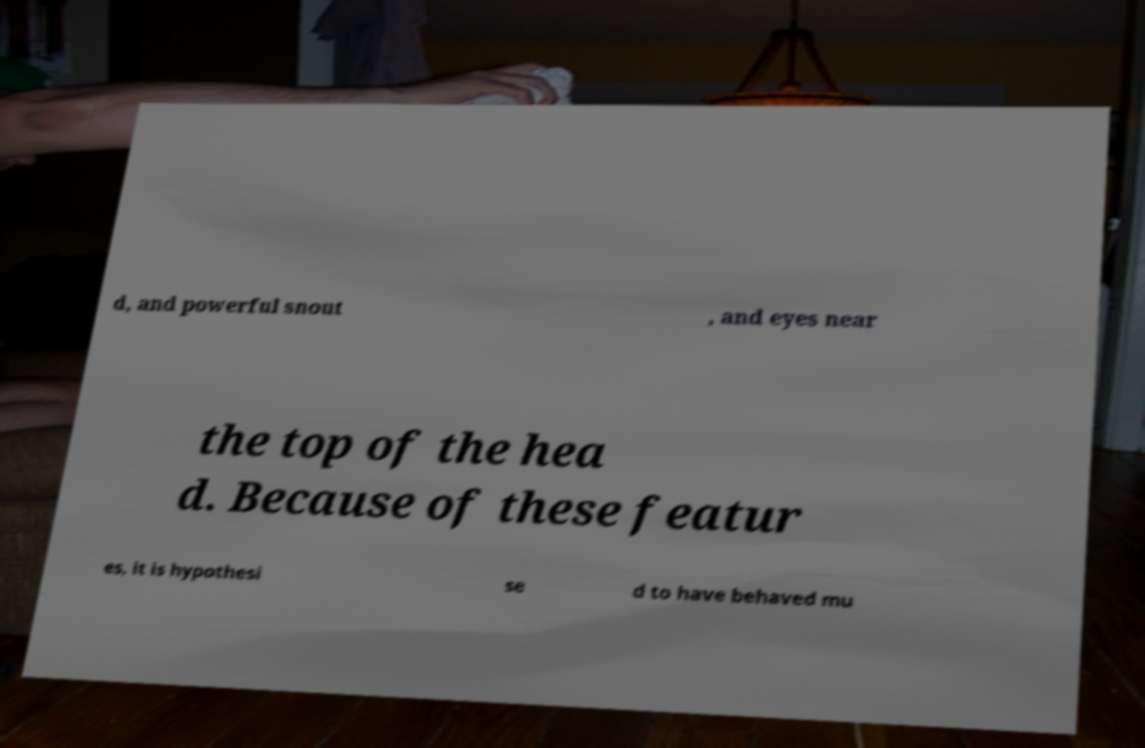There's text embedded in this image that I need extracted. Can you transcribe it verbatim? d, and powerful snout , and eyes near the top of the hea d. Because of these featur es, it is hypothesi se d to have behaved mu 